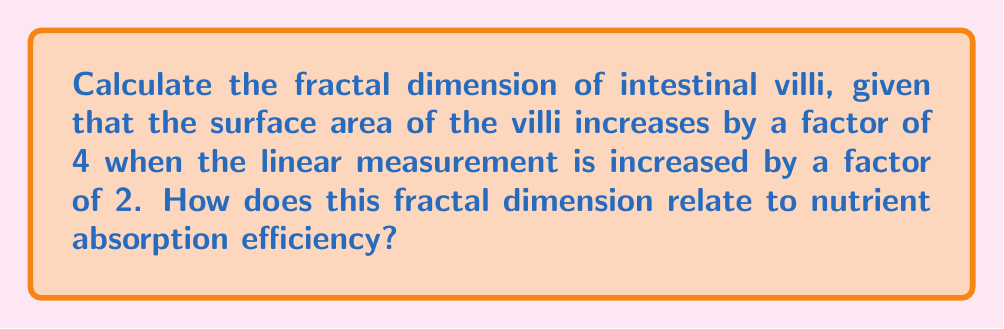Provide a solution to this math problem. To calculate the fractal dimension, we'll use the box-counting method:

1) The general formula for fractal dimension (D) is:
   $$D = \frac{\log(N)}{\log(1/r)}$$
   where N is the number of self-similar pieces and r is the scale factor.

2) In this case, we're told that when the linear measurement increases by a factor of 2, the surface area increases by a factor of 4. This means:
   $N = 4$ (surface area factor)
   $r = 1/2$ (reciprocal of linear measurement factor)

3) Plugging these values into our formula:
   $$D = \frac{\log(4)}{\log(1/(1/2))} = \frac{\log(4)}{\log(2)}$$

4) Simplify:
   $$D = \frac{2\log(2)}{\log(2)} = 2$$

5) Interpretation: A fractal dimension of 2 for the intestinal villi suggests that they behave more like a surface than a line (dimension 1) or a volume (dimension 3). This increased dimensionality between 2 and 3 allows for greater surface area in a confined space, which is crucial for nutrient absorption.

6) Relation to nutrient absorption: The fractal nature of villi optimizes the surface area-to-volume ratio of the intestinal lining. A higher fractal dimension indicates more efficient space-filling, allowing for increased contact between nutrients and absorption surfaces. This translates to enhanced nutrient absorption capacity without requiring a proportional increase in intestinal size.
Answer: $D = 2$ 